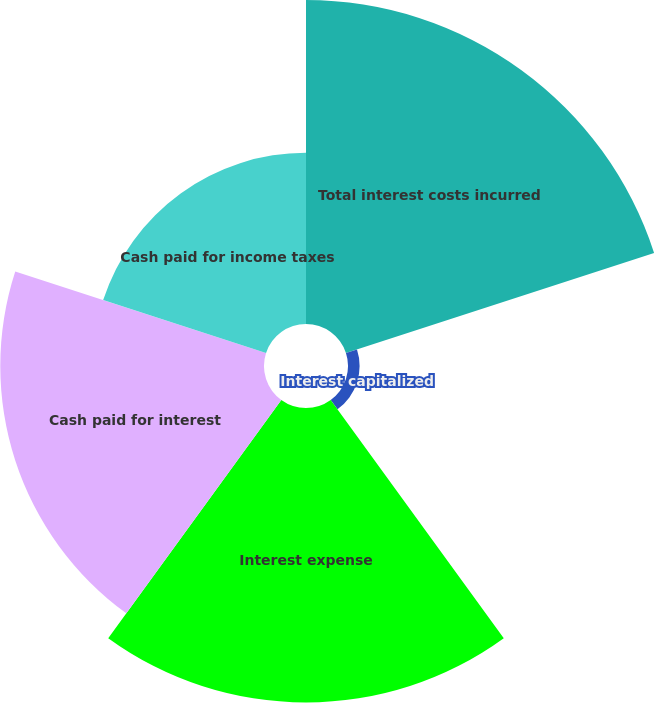Convert chart to OTSL. <chart><loc_0><loc_0><loc_500><loc_500><pie_chart><fcel>Total interest costs incurred<fcel>Interest capitalized<fcel>Interest expense<fcel>Cash paid for interest<fcel>Cash paid for income taxes<nl><fcel>30.42%<fcel>1.09%<fcel>27.65%<fcel>24.76%<fcel>16.08%<nl></chart> 